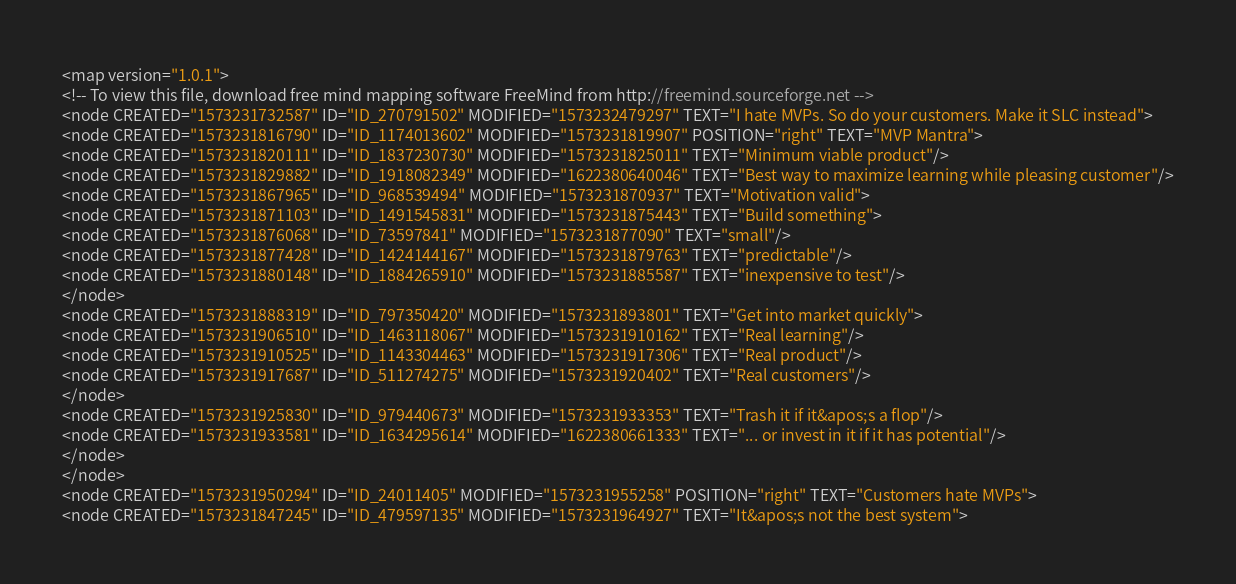Convert code to text. <code><loc_0><loc_0><loc_500><loc_500><_ObjectiveC_><map version="1.0.1">
<!-- To view this file, download free mind mapping software FreeMind from http://freemind.sourceforge.net -->
<node CREATED="1573231732587" ID="ID_270791502" MODIFIED="1573232479297" TEXT="I hate MVPs. So do your customers. Make it SLC instead">
<node CREATED="1573231816790" ID="ID_1174013602" MODIFIED="1573231819907" POSITION="right" TEXT="MVP Mantra">
<node CREATED="1573231820111" ID="ID_1837230730" MODIFIED="1573231825011" TEXT="Minimum viable product"/>
<node CREATED="1573231829882" ID="ID_1918082349" MODIFIED="1622380640046" TEXT="Best way to maximize learning while pleasing customer"/>
<node CREATED="1573231867965" ID="ID_968539494" MODIFIED="1573231870937" TEXT="Motivation valid">
<node CREATED="1573231871103" ID="ID_1491545831" MODIFIED="1573231875443" TEXT="Build something">
<node CREATED="1573231876068" ID="ID_73597841" MODIFIED="1573231877090" TEXT="small"/>
<node CREATED="1573231877428" ID="ID_1424144167" MODIFIED="1573231879763" TEXT="predictable"/>
<node CREATED="1573231880148" ID="ID_1884265910" MODIFIED="1573231885587" TEXT="inexpensive to test"/>
</node>
<node CREATED="1573231888319" ID="ID_797350420" MODIFIED="1573231893801" TEXT="Get into market quickly">
<node CREATED="1573231906510" ID="ID_1463118067" MODIFIED="1573231910162" TEXT="Real learning"/>
<node CREATED="1573231910525" ID="ID_1143304463" MODIFIED="1573231917306" TEXT="Real product"/>
<node CREATED="1573231917687" ID="ID_511274275" MODIFIED="1573231920402" TEXT="Real customers"/>
</node>
<node CREATED="1573231925830" ID="ID_979440673" MODIFIED="1573231933353" TEXT="Trash it if it&apos;s a flop"/>
<node CREATED="1573231933581" ID="ID_1634295614" MODIFIED="1622380661333" TEXT="... or invest in it if it has potential"/>
</node>
</node>
<node CREATED="1573231950294" ID="ID_24011405" MODIFIED="1573231955258" POSITION="right" TEXT="Customers hate MVPs">
<node CREATED="1573231847245" ID="ID_479597135" MODIFIED="1573231964927" TEXT="It&apos;s not the best system"></code> 